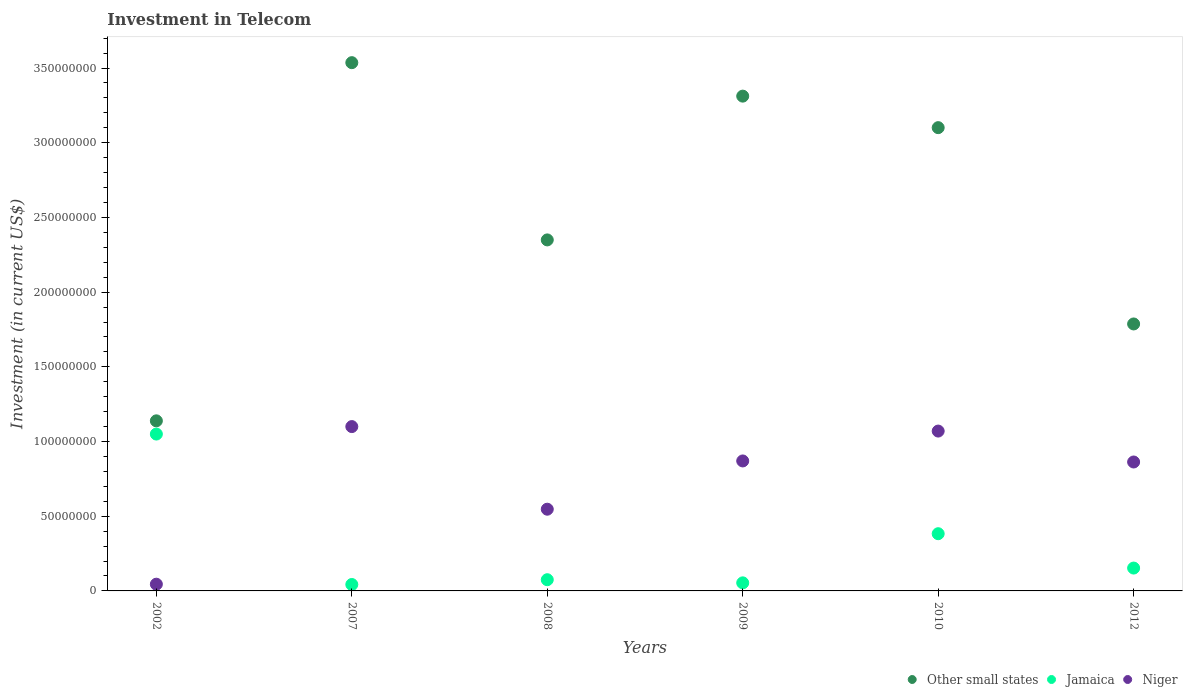How many different coloured dotlines are there?
Provide a short and direct response. 3. Is the number of dotlines equal to the number of legend labels?
Give a very brief answer. Yes. What is the amount invested in telecom in Niger in 2007?
Give a very brief answer. 1.10e+08. Across all years, what is the maximum amount invested in telecom in Jamaica?
Your answer should be compact. 1.05e+08. Across all years, what is the minimum amount invested in telecom in Other small states?
Your response must be concise. 1.14e+08. In which year was the amount invested in telecom in Other small states maximum?
Your answer should be compact. 2007. What is the total amount invested in telecom in Niger in the graph?
Keep it short and to the point. 4.50e+08. What is the difference between the amount invested in telecom in Niger in 2008 and that in 2009?
Make the answer very short. -3.23e+07. What is the difference between the amount invested in telecom in Other small states in 2012 and the amount invested in telecom in Niger in 2010?
Your response must be concise. 7.17e+07. What is the average amount invested in telecom in Niger per year?
Keep it short and to the point. 7.49e+07. In the year 2012, what is the difference between the amount invested in telecom in Jamaica and amount invested in telecom in Other small states?
Keep it short and to the point. -1.63e+08. In how many years, is the amount invested in telecom in Other small states greater than 260000000 US$?
Offer a terse response. 3. What is the ratio of the amount invested in telecom in Other small states in 2009 to that in 2010?
Your response must be concise. 1.07. Is the amount invested in telecom in Jamaica in 2007 less than that in 2010?
Provide a succinct answer. Yes. What is the difference between the highest and the second highest amount invested in telecom in Jamaica?
Keep it short and to the point. 6.67e+07. What is the difference between the highest and the lowest amount invested in telecom in Other small states?
Ensure brevity in your answer.  2.40e+08. In how many years, is the amount invested in telecom in Jamaica greater than the average amount invested in telecom in Jamaica taken over all years?
Offer a very short reply. 2. Is the amount invested in telecom in Jamaica strictly greater than the amount invested in telecom in Niger over the years?
Ensure brevity in your answer.  No. Does the graph contain any zero values?
Your answer should be compact. No. Where does the legend appear in the graph?
Provide a short and direct response. Bottom right. How many legend labels are there?
Your response must be concise. 3. How are the legend labels stacked?
Your answer should be compact. Horizontal. What is the title of the graph?
Provide a short and direct response. Investment in Telecom. What is the label or title of the Y-axis?
Offer a very short reply. Investment (in current US$). What is the Investment (in current US$) in Other small states in 2002?
Ensure brevity in your answer.  1.14e+08. What is the Investment (in current US$) in Jamaica in 2002?
Provide a succinct answer. 1.05e+08. What is the Investment (in current US$) of Niger in 2002?
Ensure brevity in your answer.  4.50e+06. What is the Investment (in current US$) of Other small states in 2007?
Make the answer very short. 3.54e+08. What is the Investment (in current US$) in Jamaica in 2007?
Your response must be concise. 4.30e+06. What is the Investment (in current US$) in Niger in 2007?
Offer a very short reply. 1.10e+08. What is the Investment (in current US$) of Other small states in 2008?
Your response must be concise. 2.35e+08. What is the Investment (in current US$) in Jamaica in 2008?
Offer a very short reply. 7.50e+06. What is the Investment (in current US$) of Niger in 2008?
Provide a succinct answer. 5.47e+07. What is the Investment (in current US$) in Other small states in 2009?
Keep it short and to the point. 3.31e+08. What is the Investment (in current US$) of Jamaica in 2009?
Provide a succinct answer. 5.40e+06. What is the Investment (in current US$) in Niger in 2009?
Provide a short and direct response. 8.70e+07. What is the Investment (in current US$) of Other small states in 2010?
Keep it short and to the point. 3.10e+08. What is the Investment (in current US$) of Jamaica in 2010?
Your answer should be very brief. 3.83e+07. What is the Investment (in current US$) of Niger in 2010?
Your answer should be compact. 1.07e+08. What is the Investment (in current US$) of Other small states in 2012?
Your answer should be very brief. 1.79e+08. What is the Investment (in current US$) in Jamaica in 2012?
Provide a succinct answer. 1.53e+07. What is the Investment (in current US$) in Niger in 2012?
Your answer should be very brief. 8.63e+07. Across all years, what is the maximum Investment (in current US$) in Other small states?
Your response must be concise. 3.54e+08. Across all years, what is the maximum Investment (in current US$) in Jamaica?
Ensure brevity in your answer.  1.05e+08. Across all years, what is the maximum Investment (in current US$) of Niger?
Make the answer very short. 1.10e+08. Across all years, what is the minimum Investment (in current US$) of Other small states?
Your response must be concise. 1.14e+08. Across all years, what is the minimum Investment (in current US$) of Jamaica?
Give a very brief answer. 4.30e+06. Across all years, what is the minimum Investment (in current US$) of Niger?
Your answer should be compact. 4.50e+06. What is the total Investment (in current US$) of Other small states in the graph?
Provide a short and direct response. 1.52e+09. What is the total Investment (in current US$) of Jamaica in the graph?
Provide a succinct answer. 1.76e+08. What is the total Investment (in current US$) of Niger in the graph?
Provide a succinct answer. 4.50e+08. What is the difference between the Investment (in current US$) in Other small states in 2002 and that in 2007?
Your answer should be compact. -2.40e+08. What is the difference between the Investment (in current US$) of Jamaica in 2002 and that in 2007?
Ensure brevity in your answer.  1.01e+08. What is the difference between the Investment (in current US$) of Niger in 2002 and that in 2007?
Provide a short and direct response. -1.06e+08. What is the difference between the Investment (in current US$) of Other small states in 2002 and that in 2008?
Ensure brevity in your answer.  -1.21e+08. What is the difference between the Investment (in current US$) of Jamaica in 2002 and that in 2008?
Ensure brevity in your answer.  9.75e+07. What is the difference between the Investment (in current US$) of Niger in 2002 and that in 2008?
Ensure brevity in your answer.  -5.02e+07. What is the difference between the Investment (in current US$) of Other small states in 2002 and that in 2009?
Provide a succinct answer. -2.17e+08. What is the difference between the Investment (in current US$) of Jamaica in 2002 and that in 2009?
Your answer should be compact. 9.96e+07. What is the difference between the Investment (in current US$) in Niger in 2002 and that in 2009?
Give a very brief answer. -8.25e+07. What is the difference between the Investment (in current US$) in Other small states in 2002 and that in 2010?
Your answer should be very brief. -1.96e+08. What is the difference between the Investment (in current US$) in Jamaica in 2002 and that in 2010?
Give a very brief answer. 6.67e+07. What is the difference between the Investment (in current US$) in Niger in 2002 and that in 2010?
Your response must be concise. -1.02e+08. What is the difference between the Investment (in current US$) in Other small states in 2002 and that in 2012?
Provide a short and direct response. -6.48e+07. What is the difference between the Investment (in current US$) of Jamaica in 2002 and that in 2012?
Your response must be concise. 8.97e+07. What is the difference between the Investment (in current US$) in Niger in 2002 and that in 2012?
Your answer should be compact. -8.18e+07. What is the difference between the Investment (in current US$) of Other small states in 2007 and that in 2008?
Provide a short and direct response. 1.19e+08. What is the difference between the Investment (in current US$) of Jamaica in 2007 and that in 2008?
Make the answer very short. -3.20e+06. What is the difference between the Investment (in current US$) in Niger in 2007 and that in 2008?
Offer a very short reply. 5.53e+07. What is the difference between the Investment (in current US$) of Other small states in 2007 and that in 2009?
Your response must be concise. 2.24e+07. What is the difference between the Investment (in current US$) of Jamaica in 2007 and that in 2009?
Your answer should be compact. -1.10e+06. What is the difference between the Investment (in current US$) in Niger in 2007 and that in 2009?
Give a very brief answer. 2.30e+07. What is the difference between the Investment (in current US$) in Other small states in 2007 and that in 2010?
Your answer should be compact. 4.35e+07. What is the difference between the Investment (in current US$) in Jamaica in 2007 and that in 2010?
Give a very brief answer. -3.40e+07. What is the difference between the Investment (in current US$) of Niger in 2007 and that in 2010?
Your answer should be very brief. 3.00e+06. What is the difference between the Investment (in current US$) in Other small states in 2007 and that in 2012?
Your response must be concise. 1.75e+08. What is the difference between the Investment (in current US$) in Jamaica in 2007 and that in 2012?
Offer a terse response. -1.10e+07. What is the difference between the Investment (in current US$) of Niger in 2007 and that in 2012?
Your answer should be very brief. 2.37e+07. What is the difference between the Investment (in current US$) in Other small states in 2008 and that in 2009?
Your answer should be very brief. -9.62e+07. What is the difference between the Investment (in current US$) in Jamaica in 2008 and that in 2009?
Make the answer very short. 2.10e+06. What is the difference between the Investment (in current US$) of Niger in 2008 and that in 2009?
Give a very brief answer. -3.23e+07. What is the difference between the Investment (in current US$) in Other small states in 2008 and that in 2010?
Offer a very short reply. -7.51e+07. What is the difference between the Investment (in current US$) of Jamaica in 2008 and that in 2010?
Give a very brief answer. -3.08e+07. What is the difference between the Investment (in current US$) in Niger in 2008 and that in 2010?
Your response must be concise. -5.23e+07. What is the difference between the Investment (in current US$) in Other small states in 2008 and that in 2012?
Your answer should be compact. 5.63e+07. What is the difference between the Investment (in current US$) in Jamaica in 2008 and that in 2012?
Provide a succinct answer. -7.80e+06. What is the difference between the Investment (in current US$) in Niger in 2008 and that in 2012?
Ensure brevity in your answer.  -3.16e+07. What is the difference between the Investment (in current US$) of Other small states in 2009 and that in 2010?
Your response must be concise. 2.11e+07. What is the difference between the Investment (in current US$) of Jamaica in 2009 and that in 2010?
Provide a succinct answer. -3.29e+07. What is the difference between the Investment (in current US$) in Niger in 2009 and that in 2010?
Offer a terse response. -2.00e+07. What is the difference between the Investment (in current US$) in Other small states in 2009 and that in 2012?
Your response must be concise. 1.52e+08. What is the difference between the Investment (in current US$) of Jamaica in 2009 and that in 2012?
Your response must be concise. -9.90e+06. What is the difference between the Investment (in current US$) of Niger in 2009 and that in 2012?
Give a very brief answer. 7.00e+05. What is the difference between the Investment (in current US$) of Other small states in 2010 and that in 2012?
Provide a succinct answer. 1.31e+08. What is the difference between the Investment (in current US$) in Jamaica in 2010 and that in 2012?
Keep it short and to the point. 2.30e+07. What is the difference between the Investment (in current US$) of Niger in 2010 and that in 2012?
Offer a terse response. 2.07e+07. What is the difference between the Investment (in current US$) of Other small states in 2002 and the Investment (in current US$) of Jamaica in 2007?
Provide a short and direct response. 1.10e+08. What is the difference between the Investment (in current US$) of Other small states in 2002 and the Investment (in current US$) of Niger in 2007?
Make the answer very short. 3.85e+06. What is the difference between the Investment (in current US$) in Jamaica in 2002 and the Investment (in current US$) in Niger in 2007?
Your response must be concise. -5.00e+06. What is the difference between the Investment (in current US$) in Other small states in 2002 and the Investment (in current US$) in Jamaica in 2008?
Provide a short and direct response. 1.06e+08. What is the difference between the Investment (in current US$) in Other small states in 2002 and the Investment (in current US$) in Niger in 2008?
Offer a very short reply. 5.92e+07. What is the difference between the Investment (in current US$) in Jamaica in 2002 and the Investment (in current US$) in Niger in 2008?
Ensure brevity in your answer.  5.03e+07. What is the difference between the Investment (in current US$) of Other small states in 2002 and the Investment (in current US$) of Jamaica in 2009?
Make the answer very short. 1.08e+08. What is the difference between the Investment (in current US$) in Other small states in 2002 and the Investment (in current US$) in Niger in 2009?
Give a very brief answer. 2.68e+07. What is the difference between the Investment (in current US$) of Jamaica in 2002 and the Investment (in current US$) of Niger in 2009?
Offer a terse response. 1.80e+07. What is the difference between the Investment (in current US$) of Other small states in 2002 and the Investment (in current US$) of Jamaica in 2010?
Offer a very short reply. 7.56e+07. What is the difference between the Investment (in current US$) of Other small states in 2002 and the Investment (in current US$) of Niger in 2010?
Give a very brief answer. 6.85e+06. What is the difference between the Investment (in current US$) of Jamaica in 2002 and the Investment (in current US$) of Niger in 2010?
Ensure brevity in your answer.  -2.00e+06. What is the difference between the Investment (in current US$) of Other small states in 2002 and the Investment (in current US$) of Jamaica in 2012?
Make the answer very short. 9.86e+07. What is the difference between the Investment (in current US$) in Other small states in 2002 and the Investment (in current US$) in Niger in 2012?
Make the answer very short. 2.76e+07. What is the difference between the Investment (in current US$) of Jamaica in 2002 and the Investment (in current US$) of Niger in 2012?
Your answer should be compact. 1.87e+07. What is the difference between the Investment (in current US$) in Other small states in 2007 and the Investment (in current US$) in Jamaica in 2008?
Provide a succinct answer. 3.46e+08. What is the difference between the Investment (in current US$) in Other small states in 2007 and the Investment (in current US$) in Niger in 2008?
Your response must be concise. 2.99e+08. What is the difference between the Investment (in current US$) in Jamaica in 2007 and the Investment (in current US$) in Niger in 2008?
Provide a short and direct response. -5.04e+07. What is the difference between the Investment (in current US$) in Other small states in 2007 and the Investment (in current US$) in Jamaica in 2009?
Ensure brevity in your answer.  3.48e+08. What is the difference between the Investment (in current US$) in Other small states in 2007 and the Investment (in current US$) in Niger in 2009?
Provide a short and direct response. 2.67e+08. What is the difference between the Investment (in current US$) in Jamaica in 2007 and the Investment (in current US$) in Niger in 2009?
Offer a terse response. -8.27e+07. What is the difference between the Investment (in current US$) in Other small states in 2007 and the Investment (in current US$) in Jamaica in 2010?
Your answer should be compact. 3.15e+08. What is the difference between the Investment (in current US$) in Other small states in 2007 and the Investment (in current US$) in Niger in 2010?
Keep it short and to the point. 2.47e+08. What is the difference between the Investment (in current US$) of Jamaica in 2007 and the Investment (in current US$) of Niger in 2010?
Provide a short and direct response. -1.03e+08. What is the difference between the Investment (in current US$) in Other small states in 2007 and the Investment (in current US$) in Jamaica in 2012?
Provide a succinct answer. 3.38e+08. What is the difference between the Investment (in current US$) of Other small states in 2007 and the Investment (in current US$) of Niger in 2012?
Offer a very short reply. 2.67e+08. What is the difference between the Investment (in current US$) of Jamaica in 2007 and the Investment (in current US$) of Niger in 2012?
Ensure brevity in your answer.  -8.20e+07. What is the difference between the Investment (in current US$) of Other small states in 2008 and the Investment (in current US$) of Jamaica in 2009?
Your answer should be compact. 2.30e+08. What is the difference between the Investment (in current US$) in Other small states in 2008 and the Investment (in current US$) in Niger in 2009?
Make the answer very short. 1.48e+08. What is the difference between the Investment (in current US$) of Jamaica in 2008 and the Investment (in current US$) of Niger in 2009?
Offer a very short reply. -7.95e+07. What is the difference between the Investment (in current US$) in Other small states in 2008 and the Investment (in current US$) in Jamaica in 2010?
Make the answer very short. 1.97e+08. What is the difference between the Investment (in current US$) of Other small states in 2008 and the Investment (in current US$) of Niger in 2010?
Offer a terse response. 1.28e+08. What is the difference between the Investment (in current US$) of Jamaica in 2008 and the Investment (in current US$) of Niger in 2010?
Make the answer very short. -9.95e+07. What is the difference between the Investment (in current US$) of Other small states in 2008 and the Investment (in current US$) of Jamaica in 2012?
Your response must be concise. 2.20e+08. What is the difference between the Investment (in current US$) of Other small states in 2008 and the Investment (in current US$) of Niger in 2012?
Your response must be concise. 1.49e+08. What is the difference between the Investment (in current US$) of Jamaica in 2008 and the Investment (in current US$) of Niger in 2012?
Give a very brief answer. -7.88e+07. What is the difference between the Investment (in current US$) in Other small states in 2009 and the Investment (in current US$) in Jamaica in 2010?
Your response must be concise. 2.93e+08. What is the difference between the Investment (in current US$) in Other small states in 2009 and the Investment (in current US$) in Niger in 2010?
Your response must be concise. 2.24e+08. What is the difference between the Investment (in current US$) in Jamaica in 2009 and the Investment (in current US$) in Niger in 2010?
Your response must be concise. -1.02e+08. What is the difference between the Investment (in current US$) of Other small states in 2009 and the Investment (in current US$) of Jamaica in 2012?
Your answer should be compact. 3.16e+08. What is the difference between the Investment (in current US$) in Other small states in 2009 and the Investment (in current US$) in Niger in 2012?
Provide a succinct answer. 2.45e+08. What is the difference between the Investment (in current US$) in Jamaica in 2009 and the Investment (in current US$) in Niger in 2012?
Make the answer very short. -8.09e+07. What is the difference between the Investment (in current US$) of Other small states in 2010 and the Investment (in current US$) of Jamaica in 2012?
Ensure brevity in your answer.  2.95e+08. What is the difference between the Investment (in current US$) of Other small states in 2010 and the Investment (in current US$) of Niger in 2012?
Offer a very short reply. 2.24e+08. What is the difference between the Investment (in current US$) of Jamaica in 2010 and the Investment (in current US$) of Niger in 2012?
Make the answer very short. -4.80e+07. What is the average Investment (in current US$) of Other small states per year?
Provide a short and direct response. 2.54e+08. What is the average Investment (in current US$) in Jamaica per year?
Offer a very short reply. 2.93e+07. What is the average Investment (in current US$) in Niger per year?
Your answer should be very brief. 7.49e+07. In the year 2002, what is the difference between the Investment (in current US$) of Other small states and Investment (in current US$) of Jamaica?
Offer a very short reply. 8.85e+06. In the year 2002, what is the difference between the Investment (in current US$) of Other small states and Investment (in current US$) of Niger?
Offer a terse response. 1.09e+08. In the year 2002, what is the difference between the Investment (in current US$) in Jamaica and Investment (in current US$) in Niger?
Give a very brief answer. 1.00e+08. In the year 2007, what is the difference between the Investment (in current US$) in Other small states and Investment (in current US$) in Jamaica?
Provide a succinct answer. 3.49e+08. In the year 2007, what is the difference between the Investment (in current US$) in Other small states and Investment (in current US$) in Niger?
Your response must be concise. 2.44e+08. In the year 2007, what is the difference between the Investment (in current US$) of Jamaica and Investment (in current US$) of Niger?
Offer a very short reply. -1.06e+08. In the year 2008, what is the difference between the Investment (in current US$) of Other small states and Investment (in current US$) of Jamaica?
Your response must be concise. 2.27e+08. In the year 2008, what is the difference between the Investment (in current US$) of Other small states and Investment (in current US$) of Niger?
Ensure brevity in your answer.  1.80e+08. In the year 2008, what is the difference between the Investment (in current US$) of Jamaica and Investment (in current US$) of Niger?
Keep it short and to the point. -4.72e+07. In the year 2009, what is the difference between the Investment (in current US$) in Other small states and Investment (in current US$) in Jamaica?
Offer a very short reply. 3.26e+08. In the year 2009, what is the difference between the Investment (in current US$) of Other small states and Investment (in current US$) of Niger?
Make the answer very short. 2.44e+08. In the year 2009, what is the difference between the Investment (in current US$) of Jamaica and Investment (in current US$) of Niger?
Your answer should be very brief. -8.16e+07. In the year 2010, what is the difference between the Investment (in current US$) in Other small states and Investment (in current US$) in Jamaica?
Provide a succinct answer. 2.72e+08. In the year 2010, what is the difference between the Investment (in current US$) of Other small states and Investment (in current US$) of Niger?
Keep it short and to the point. 2.03e+08. In the year 2010, what is the difference between the Investment (in current US$) of Jamaica and Investment (in current US$) of Niger?
Your answer should be compact. -6.87e+07. In the year 2012, what is the difference between the Investment (in current US$) in Other small states and Investment (in current US$) in Jamaica?
Provide a short and direct response. 1.63e+08. In the year 2012, what is the difference between the Investment (in current US$) in Other small states and Investment (in current US$) in Niger?
Provide a short and direct response. 9.24e+07. In the year 2012, what is the difference between the Investment (in current US$) in Jamaica and Investment (in current US$) in Niger?
Your response must be concise. -7.10e+07. What is the ratio of the Investment (in current US$) in Other small states in 2002 to that in 2007?
Offer a terse response. 0.32. What is the ratio of the Investment (in current US$) in Jamaica in 2002 to that in 2007?
Your answer should be very brief. 24.42. What is the ratio of the Investment (in current US$) of Niger in 2002 to that in 2007?
Provide a short and direct response. 0.04. What is the ratio of the Investment (in current US$) in Other small states in 2002 to that in 2008?
Give a very brief answer. 0.48. What is the ratio of the Investment (in current US$) in Jamaica in 2002 to that in 2008?
Your answer should be very brief. 14. What is the ratio of the Investment (in current US$) in Niger in 2002 to that in 2008?
Keep it short and to the point. 0.08. What is the ratio of the Investment (in current US$) in Other small states in 2002 to that in 2009?
Ensure brevity in your answer.  0.34. What is the ratio of the Investment (in current US$) of Jamaica in 2002 to that in 2009?
Give a very brief answer. 19.44. What is the ratio of the Investment (in current US$) in Niger in 2002 to that in 2009?
Ensure brevity in your answer.  0.05. What is the ratio of the Investment (in current US$) in Other small states in 2002 to that in 2010?
Provide a succinct answer. 0.37. What is the ratio of the Investment (in current US$) of Jamaica in 2002 to that in 2010?
Give a very brief answer. 2.74. What is the ratio of the Investment (in current US$) of Niger in 2002 to that in 2010?
Offer a terse response. 0.04. What is the ratio of the Investment (in current US$) of Other small states in 2002 to that in 2012?
Offer a terse response. 0.64. What is the ratio of the Investment (in current US$) of Jamaica in 2002 to that in 2012?
Offer a very short reply. 6.86. What is the ratio of the Investment (in current US$) of Niger in 2002 to that in 2012?
Provide a short and direct response. 0.05. What is the ratio of the Investment (in current US$) of Other small states in 2007 to that in 2008?
Offer a very short reply. 1.5. What is the ratio of the Investment (in current US$) of Jamaica in 2007 to that in 2008?
Make the answer very short. 0.57. What is the ratio of the Investment (in current US$) in Niger in 2007 to that in 2008?
Provide a short and direct response. 2.01. What is the ratio of the Investment (in current US$) of Other small states in 2007 to that in 2009?
Provide a short and direct response. 1.07. What is the ratio of the Investment (in current US$) of Jamaica in 2007 to that in 2009?
Keep it short and to the point. 0.8. What is the ratio of the Investment (in current US$) in Niger in 2007 to that in 2009?
Make the answer very short. 1.26. What is the ratio of the Investment (in current US$) of Other small states in 2007 to that in 2010?
Keep it short and to the point. 1.14. What is the ratio of the Investment (in current US$) of Jamaica in 2007 to that in 2010?
Your response must be concise. 0.11. What is the ratio of the Investment (in current US$) in Niger in 2007 to that in 2010?
Offer a terse response. 1.03. What is the ratio of the Investment (in current US$) of Other small states in 2007 to that in 2012?
Make the answer very short. 1.98. What is the ratio of the Investment (in current US$) of Jamaica in 2007 to that in 2012?
Provide a succinct answer. 0.28. What is the ratio of the Investment (in current US$) in Niger in 2007 to that in 2012?
Your response must be concise. 1.27. What is the ratio of the Investment (in current US$) of Other small states in 2008 to that in 2009?
Offer a very short reply. 0.71. What is the ratio of the Investment (in current US$) in Jamaica in 2008 to that in 2009?
Ensure brevity in your answer.  1.39. What is the ratio of the Investment (in current US$) of Niger in 2008 to that in 2009?
Your answer should be very brief. 0.63. What is the ratio of the Investment (in current US$) of Other small states in 2008 to that in 2010?
Your answer should be compact. 0.76. What is the ratio of the Investment (in current US$) of Jamaica in 2008 to that in 2010?
Your answer should be compact. 0.2. What is the ratio of the Investment (in current US$) in Niger in 2008 to that in 2010?
Offer a terse response. 0.51. What is the ratio of the Investment (in current US$) of Other small states in 2008 to that in 2012?
Provide a succinct answer. 1.31. What is the ratio of the Investment (in current US$) of Jamaica in 2008 to that in 2012?
Provide a succinct answer. 0.49. What is the ratio of the Investment (in current US$) of Niger in 2008 to that in 2012?
Give a very brief answer. 0.63. What is the ratio of the Investment (in current US$) of Other small states in 2009 to that in 2010?
Give a very brief answer. 1.07. What is the ratio of the Investment (in current US$) in Jamaica in 2009 to that in 2010?
Make the answer very short. 0.14. What is the ratio of the Investment (in current US$) in Niger in 2009 to that in 2010?
Your response must be concise. 0.81. What is the ratio of the Investment (in current US$) in Other small states in 2009 to that in 2012?
Make the answer very short. 1.85. What is the ratio of the Investment (in current US$) in Jamaica in 2009 to that in 2012?
Make the answer very short. 0.35. What is the ratio of the Investment (in current US$) of Niger in 2009 to that in 2012?
Your response must be concise. 1.01. What is the ratio of the Investment (in current US$) in Other small states in 2010 to that in 2012?
Make the answer very short. 1.74. What is the ratio of the Investment (in current US$) of Jamaica in 2010 to that in 2012?
Offer a very short reply. 2.5. What is the ratio of the Investment (in current US$) of Niger in 2010 to that in 2012?
Your answer should be compact. 1.24. What is the difference between the highest and the second highest Investment (in current US$) of Other small states?
Offer a very short reply. 2.24e+07. What is the difference between the highest and the second highest Investment (in current US$) of Jamaica?
Provide a short and direct response. 6.67e+07. What is the difference between the highest and the lowest Investment (in current US$) in Other small states?
Offer a very short reply. 2.40e+08. What is the difference between the highest and the lowest Investment (in current US$) of Jamaica?
Keep it short and to the point. 1.01e+08. What is the difference between the highest and the lowest Investment (in current US$) in Niger?
Offer a very short reply. 1.06e+08. 